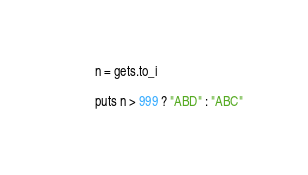<code> <loc_0><loc_0><loc_500><loc_500><_Ruby_>n = gets.to_i

puts n > 999 ? "ABD" : "ABC"

</code> 